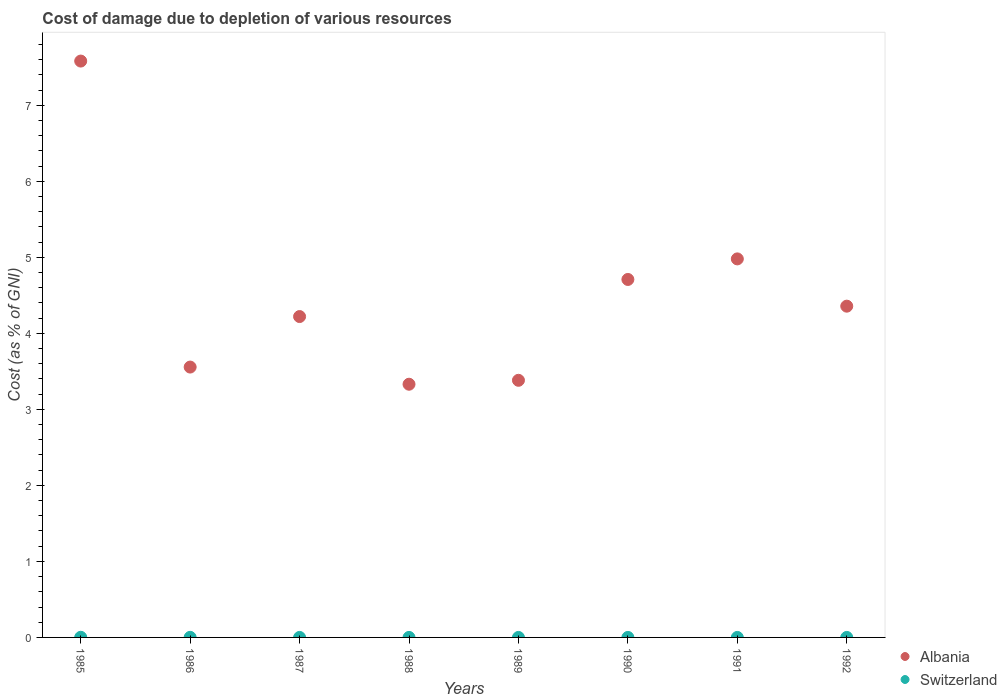What is the cost of damage caused due to the depletion of various resources in Albania in 1990?
Your response must be concise. 4.71. Across all years, what is the maximum cost of damage caused due to the depletion of various resources in Switzerland?
Your response must be concise. 0. Across all years, what is the minimum cost of damage caused due to the depletion of various resources in Albania?
Make the answer very short. 3.33. In which year was the cost of damage caused due to the depletion of various resources in Switzerland maximum?
Offer a very short reply. 1985. In which year was the cost of damage caused due to the depletion of various resources in Switzerland minimum?
Provide a succinct answer. 1992. What is the total cost of damage caused due to the depletion of various resources in Switzerland in the graph?
Give a very brief answer. 0. What is the difference between the cost of damage caused due to the depletion of various resources in Albania in 1987 and that in 1991?
Ensure brevity in your answer.  -0.76. What is the difference between the cost of damage caused due to the depletion of various resources in Switzerland in 1985 and the cost of damage caused due to the depletion of various resources in Albania in 1989?
Offer a very short reply. -3.38. What is the average cost of damage caused due to the depletion of various resources in Albania per year?
Offer a very short reply. 4.51. In the year 1992, what is the difference between the cost of damage caused due to the depletion of various resources in Switzerland and cost of damage caused due to the depletion of various resources in Albania?
Offer a terse response. -4.36. In how many years, is the cost of damage caused due to the depletion of various resources in Switzerland greater than 5.4 %?
Your response must be concise. 0. What is the ratio of the cost of damage caused due to the depletion of various resources in Albania in 1988 to that in 1989?
Your answer should be very brief. 0.98. What is the difference between the highest and the second highest cost of damage caused due to the depletion of various resources in Albania?
Provide a succinct answer. 2.6. What is the difference between the highest and the lowest cost of damage caused due to the depletion of various resources in Albania?
Provide a short and direct response. 4.25. In how many years, is the cost of damage caused due to the depletion of various resources in Switzerland greater than the average cost of damage caused due to the depletion of various resources in Switzerland taken over all years?
Give a very brief answer. 2. Is the sum of the cost of damage caused due to the depletion of various resources in Albania in 1990 and 1992 greater than the maximum cost of damage caused due to the depletion of various resources in Switzerland across all years?
Your answer should be very brief. Yes. Does the cost of damage caused due to the depletion of various resources in Albania monotonically increase over the years?
Provide a succinct answer. No. Is the cost of damage caused due to the depletion of various resources in Switzerland strictly greater than the cost of damage caused due to the depletion of various resources in Albania over the years?
Your response must be concise. No. Is the cost of damage caused due to the depletion of various resources in Albania strictly less than the cost of damage caused due to the depletion of various resources in Switzerland over the years?
Offer a very short reply. No. How many dotlines are there?
Offer a terse response. 2. What is the difference between two consecutive major ticks on the Y-axis?
Offer a very short reply. 1. Are the values on the major ticks of Y-axis written in scientific E-notation?
Your response must be concise. No. Does the graph contain grids?
Provide a short and direct response. No. How many legend labels are there?
Your response must be concise. 2. How are the legend labels stacked?
Provide a succinct answer. Vertical. What is the title of the graph?
Your answer should be very brief. Cost of damage due to depletion of various resources. What is the label or title of the X-axis?
Your answer should be very brief. Years. What is the label or title of the Y-axis?
Offer a very short reply. Cost (as % of GNI). What is the Cost (as % of GNI) in Albania in 1985?
Provide a short and direct response. 7.58. What is the Cost (as % of GNI) in Switzerland in 1985?
Keep it short and to the point. 0. What is the Cost (as % of GNI) in Albania in 1986?
Provide a succinct answer. 3.56. What is the Cost (as % of GNI) of Switzerland in 1986?
Make the answer very short. 0. What is the Cost (as % of GNI) of Albania in 1987?
Provide a short and direct response. 4.22. What is the Cost (as % of GNI) in Switzerland in 1987?
Make the answer very short. 0. What is the Cost (as % of GNI) in Albania in 1988?
Keep it short and to the point. 3.33. What is the Cost (as % of GNI) in Switzerland in 1988?
Ensure brevity in your answer.  9.86323820168902e-5. What is the Cost (as % of GNI) in Albania in 1989?
Your response must be concise. 3.38. What is the Cost (as % of GNI) of Switzerland in 1989?
Give a very brief answer. 5.30297084676029e-5. What is the Cost (as % of GNI) in Albania in 1990?
Provide a short and direct response. 4.71. What is the Cost (as % of GNI) of Switzerland in 1990?
Keep it short and to the point. 5.737427728367479e-5. What is the Cost (as % of GNI) of Albania in 1991?
Offer a very short reply. 4.98. What is the Cost (as % of GNI) of Switzerland in 1991?
Your answer should be compact. 4.359630859095721e-5. What is the Cost (as % of GNI) in Albania in 1992?
Your answer should be very brief. 4.36. What is the Cost (as % of GNI) of Switzerland in 1992?
Provide a short and direct response. 3.75649927603136e-5. Across all years, what is the maximum Cost (as % of GNI) of Albania?
Keep it short and to the point. 7.58. Across all years, what is the maximum Cost (as % of GNI) of Switzerland?
Make the answer very short. 0. Across all years, what is the minimum Cost (as % of GNI) of Albania?
Give a very brief answer. 3.33. Across all years, what is the minimum Cost (as % of GNI) in Switzerland?
Ensure brevity in your answer.  3.75649927603136e-5. What is the total Cost (as % of GNI) of Albania in the graph?
Your answer should be compact. 36.11. What is the total Cost (as % of GNI) of Switzerland in the graph?
Your answer should be very brief. 0. What is the difference between the Cost (as % of GNI) of Albania in 1985 and that in 1986?
Keep it short and to the point. 4.02. What is the difference between the Cost (as % of GNI) in Switzerland in 1985 and that in 1986?
Your answer should be very brief. 0. What is the difference between the Cost (as % of GNI) of Albania in 1985 and that in 1987?
Your response must be concise. 3.36. What is the difference between the Cost (as % of GNI) in Switzerland in 1985 and that in 1987?
Offer a terse response. 0. What is the difference between the Cost (as % of GNI) in Albania in 1985 and that in 1988?
Make the answer very short. 4.25. What is the difference between the Cost (as % of GNI) in Switzerland in 1985 and that in 1988?
Your answer should be compact. 0. What is the difference between the Cost (as % of GNI) in Albania in 1985 and that in 1989?
Make the answer very short. 4.2. What is the difference between the Cost (as % of GNI) in Switzerland in 1985 and that in 1989?
Your response must be concise. 0. What is the difference between the Cost (as % of GNI) in Albania in 1985 and that in 1990?
Your response must be concise. 2.87. What is the difference between the Cost (as % of GNI) of Switzerland in 1985 and that in 1990?
Ensure brevity in your answer.  0. What is the difference between the Cost (as % of GNI) in Albania in 1985 and that in 1991?
Offer a terse response. 2.6. What is the difference between the Cost (as % of GNI) of Switzerland in 1985 and that in 1991?
Offer a terse response. 0. What is the difference between the Cost (as % of GNI) in Albania in 1985 and that in 1992?
Your response must be concise. 3.22. What is the difference between the Cost (as % of GNI) in Switzerland in 1985 and that in 1992?
Offer a terse response. 0. What is the difference between the Cost (as % of GNI) of Albania in 1986 and that in 1987?
Keep it short and to the point. -0.66. What is the difference between the Cost (as % of GNI) of Switzerland in 1986 and that in 1987?
Make the answer very short. 0. What is the difference between the Cost (as % of GNI) in Albania in 1986 and that in 1988?
Offer a terse response. 0.23. What is the difference between the Cost (as % of GNI) of Switzerland in 1986 and that in 1988?
Your answer should be compact. 0. What is the difference between the Cost (as % of GNI) of Albania in 1986 and that in 1989?
Your answer should be very brief. 0.17. What is the difference between the Cost (as % of GNI) of Switzerland in 1986 and that in 1989?
Your answer should be very brief. 0. What is the difference between the Cost (as % of GNI) in Albania in 1986 and that in 1990?
Provide a succinct answer. -1.15. What is the difference between the Cost (as % of GNI) in Switzerland in 1986 and that in 1990?
Ensure brevity in your answer.  0. What is the difference between the Cost (as % of GNI) in Albania in 1986 and that in 1991?
Keep it short and to the point. -1.42. What is the difference between the Cost (as % of GNI) of Switzerland in 1986 and that in 1991?
Keep it short and to the point. 0. What is the difference between the Cost (as % of GNI) in Albania in 1986 and that in 1992?
Ensure brevity in your answer.  -0.8. What is the difference between the Cost (as % of GNI) of Switzerland in 1986 and that in 1992?
Keep it short and to the point. 0. What is the difference between the Cost (as % of GNI) of Albania in 1987 and that in 1988?
Ensure brevity in your answer.  0.89. What is the difference between the Cost (as % of GNI) in Switzerland in 1987 and that in 1988?
Ensure brevity in your answer.  0. What is the difference between the Cost (as % of GNI) in Albania in 1987 and that in 1989?
Offer a terse response. 0.84. What is the difference between the Cost (as % of GNI) in Albania in 1987 and that in 1990?
Ensure brevity in your answer.  -0.49. What is the difference between the Cost (as % of GNI) in Switzerland in 1987 and that in 1990?
Provide a short and direct response. 0. What is the difference between the Cost (as % of GNI) of Albania in 1987 and that in 1991?
Keep it short and to the point. -0.76. What is the difference between the Cost (as % of GNI) in Switzerland in 1987 and that in 1991?
Offer a very short reply. 0. What is the difference between the Cost (as % of GNI) in Albania in 1987 and that in 1992?
Make the answer very short. -0.14. What is the difference between the Cost (as % of GNI) in Switzerland in 1987 and that in 1992?
Provide a succinct answer. 0. What is the difference between the Cost (as % of GNI) of Albania in 1988 and that in 1989?
Give a very brief answer. -0.05. What is the difference between the Cost (as % of GNI) of Switzerland in 1988 and that in 1989?
Your answer should be compact. 0. What is the difference between the Cost (as % of GNI) in Albania in 1988 and that in 1990?
Give a very brief answer. -1.38. What is the difference between the Cost (as % of GNI) of Albania in 1988 and that in 1991?
Offer a very short reply. -1.65. What is the difference between the Cost (as % of GNI) in Albania in 1988 and that in 1992?
Give a very brief answer. -1.03. What is the difference between the Cost (as % of GNI) in Albania in 1989 and that in 1990?
Your answer should be very brief. -1.33. What is the difference between the Cost (as % of GNI) in Switzerland in 1989 and that in 1990?
Keep it short and to the point. -0. What is the difference between the Cost (as % of GNI) of Albania in 1989 and that in 1991?
Provide a succinct answer. -1.6. What is the difference between the Cost (as % of GNI) in Switzerland in 1989 and that in 1991?
Your answer should be compact. 0. What is the difference between the Cost (as % of GNI) of Albania in 1989 and that in 1992?
Offer a very short reply. -0.97. What is the difference between the Cost (as % of GNI) of Albania in 1990 and that in 1991?
Your answer should be compact. -0.27. What is the difference between the Cost (as % of GNI) of Albania in 1990 and that in 1992?
Your answer should be very brief. 0.35. What is the difference between the Cost (as % of GNI) in Albania in 1991 and that in 1992?
Your response must be concise. 0.62. What is the difference between the Cost (as % of GNI) in Switzerland in 1991 and that in 1992?
Keep it short and to the point. 0. What is the difference between the Cost (as % of GNI) in Albania in 1985 and the Cost (as % of GNI) in Switzerland in 1986?
Your answer should be compact. 7.58. What is the difference between the Cost (as % of GNI) in Albania in 1985 and the Cost (as % of GNI) in Switzerland in 1987?
Your response must be concise. 7.58. What is the difference between the Cost (as % of GNI) of Albania in 1985 and the Cost (as % of GNI) of Switzerland in 1988?
Your answer should be very brief. 7.58. What is the difference between the Cost (as % of GNI) of Albania in 1985 and the Cost (as % of GNI) of Switzerland in 1989?
Offer a terse response. 7.58. What is the difference between the Cost (as % of GNI) of Albania in 1985 and the Cost (as % of GNI) of Switzerland in 1990?
Your response must be concise. 7.58. What is the difference between the Cost (as % of GNI) of Albania in 1985 and the Cost (as % of GNI) of Switzerland in 1991?
Keep it short and to the point. 7.58. What is the difference between the Cost (as % of GNI) of Albania in 1985 and the Cost (as % of GNI) of Switzerland in 1992?
Offer a terse response. 7.58. What is the difference between the Cost (as % of GNI) in Albania in 1986 and the Cost (as % of GNI) in Switzerland in 1987?
Ensure brevity in your answer.  3.56. What is the difference between the Cost (as % of GNI) in Albania in 1986 and the Cost (as % of GNI) in Switzerland in 1988?
Provide a succinct answer. 3.56. What is the difference between the Cost (as % of GNI) in Albania in 1986 and the Cost (as % of GNI) in Switzerland in 1989?
Offer a very short reply. 3.56. What is the difference between the Cost (as % of GNI) in Albania in 1986 and the Cost (as % of GNI) in Switzerland in 1990?
Your response must be concise. 3.56. What is the difference between the Cost (as % of GNI) of Albania in 1986 and the Cost (as % of GNI) of Switzerland in 1991?
Keep it short and to the point. 3.56. What is the difference between the Cost (as % of GNI) of Albania in 1986 and the Cost (as % of GNI) of Switzerland in 1992?
Your answer should be compact. 3.56. What is the difference between the Cost (as % of GNI) of Albania in 1987 and the Cost (as % of GNI) of Switzerland in 1988?
Keep it short and to the point. 4.22. What is the difference between the Cost (as % of GNI) in Albania in 1987 and the Cost (as % of GNI) in Switzerland in 1989?
Make the answer very short. 4.22. What is the difference between the Cost (as % of GNI) in Albania in 1987 and the Cost (as % of GNI) in Switzerland in 1990?
Keep it short and to the point. 4.22. What is the difference between the Cost (as % of GNI) in Albania in 1987 and the Cost (as % of GNI) in Switzerland in 1991?
Give a very brief answer. 4.22. What is the difference between the Cost (as % of GNI) in Albania in 1987 and the Cost (as % of GNI) in Switzerland in 1992?
Your answer should be compact. 4.22. What is the difference between the Cost (as % of GNI) in Albania in 1988 and the Cost (as % of GNI) in Switzerland in 1989?
Your answer should be very brief. 3.33. What is the difference between the Cost (as % of GNI) of Albania in 1988 and the Cost (as % of GNI) of Switzerland in 1990?
Your answer should be compact. 3.33. What is the difference between the Cost (as % of GNI) in Albania in 1988 and the Cost (as % of GNI) in Switzerland in 1991?
Give a very brief answer. 3.33. What is the difference between the Cost (as % of GNI) of Albania in 1988 and the Cost (as % of GNI) of Switzerland in 1992?
Keep it short and to the point. 3.33. What is the difference between the Cost (as % of GNI) in Albania in 1989 and the Cost (as % of GNI) in Switzerland in 1990?
Your answer should be compact. 3.38. What is the difference between the Cost (as % of GNI) in Albania in 1989 and the Cost (as % of GNI) in Switzerland in 1991?
Your answer should be very brief. 3.38. What is the difference between the Cost (as % of GNI) of Albania in 1989 and the Cost (as % of GNI) of Switzerland in 1992?
Your answer should be compact. 3.38. What is the difference between the Cost (as % of GNI) of Albania in 1990 and the Cost (as % of GNI) of Switzerland in 1991?
Ensure brevity in your answer.  4.71. What is the difference between the Cost (as % of GNI) in Albania in 1990 and the Cost (as % of GNI) in Switzerland in 1992?
Your answer should be compact. 4.71. What is the difference between the Cost (as % of GNI) of Albania in 1991 and the Cost (as % of GNI) of Switzerland in 1992?
Offer a very short reply. 4.98. What is the average Cost (as % of GNI) of Albania per year?
Provide a short and direct response. 4.51. What is the average Cost (as % of GNI) in Switzerland per year?
Make the answer very short. 0. In the year 1985, what is the difference between the Cost (as % of GNI) in Albania and Cost (as % of GNI) in Switzerland?
Offer a very short reply. 7.58. In the year 1986, what is the difference between the Cost (as % of GNI) of Albania and Cost (as % of GNI) of Switzerland?
Provide a succinct answer. 3.55. In the year 1987, what is the difference between the Cost (as % of GNI) of Albania and Cost (as % of GNI) of Switzerland?
Keep it short and to the point. 4.22. In the year 1988, what is the difference between the Cost (as % of GNI) of Albania and Cost (as % of GNI) of Switzerland?
Provide a short and direct response. 3.33. In the year 1989, what is the difference between the Cost (as % of GNI) in Albania and Cost (as % of GNI) in Switzerland?
Offer a very short reply. 3.38. In the year 1990, what is the difference between the Cost (as % of GNI) in Albania and Cost (as % of GNI) in Switzerland?
Offer a very short reply. 4.71. In the year 1991, what is the difference between the Cost (as % of GNI) of Albania and Cost (as % of GNI) of Switzerland?
Offer a very short reply. 4.98. In the year 1992, what is the difference between the Cost (as % of GNI) in Albania and Cost (as % of GNI) in Switzerland?
Keep it short and to the point. 4.36. What is the ratio of the Cost (as % of GNI) of Albania in 1985 to that in 1986?
Your response must be concise. 2.13. What is the ratio of the Cost (as % of GNI) of Switzerland in 1985 to that in 1986?
Your answer should be very brief. 1.59. What is the ratio of the Cost (as % of GNI) in Albania in 1985 to that in 1987?
Your answer should be very brief. 1.8. What is the ratio of the Cost (as % of GNI) of Switzerland in 1985 to that in 1987?
Offer a terse response. 12. What is the ratio of the Cost (as % of GNI) in Albania in 1985 to that in 1988?
Offer a terse response. 2.28. What is the ratio of the Cost (as % of GNI) of Switzerland in 1985 to that in 1988?
Give a very brief answer. 18.59. What is the ratio of the Cost (as % of GNI) of Albania in 1985 to that in 1989?
Your response must be concise. 2.24. What is the ratio of the Cost (as % of GNI) in Switzerland in 1985 to that in 1989?
Your response must be concise. 34.57. What is the ratio of the Cost (as % of GNI) in Albania in 1985 to that in 1990?
Give a very brief answer. 1.61. What is the ratio of the Cost (as % of GNI) of Switzerland in 1985 to that in 1990?
Your answer should be very brief. 31.95. What is the ratio of the Cost (as % of GNI) in Albania in 1985 to that in 1991?
Your response must be concise. 1.52. What is the ratio of the Cost (as % of GNI) of Switzerland in 1985 to that in 1991?
Give a very brief answer. 42.05. What is the ratio of the Cost (as % of GNI) in Albania in 1985 to that in 1992?
Your response must be concise. 1.74. What is the ratio of the Cost (as % of GNI) of Switzerland in 1985 to that in 1992?
Offer a terse response. 48.8. What is the ratio of the Cost (as % of GNI) of Albania in 1986 to that in 1987?
Offer a very short reply. 0.84. What is the ratio of the Cost (as % of GNI) in Switzerland in 1986 to that in 1987?
Ensure brevity in your answer.  7.56. What is the ratio of the Cost (as % of GNI) in Albania in 1986 to that in 1988?
Your answer should be compact. 1.07. What is the ratio of the Cost (as % of GNI) of Switzerland in 1986 to that in 1988?
Provide a short and direct response. 11.71. What is the ratio of the Cost (as % of GNI) of Albania in 1986 to that in 1989?
Provide a short and direct response. 1.05. What is the ratio of the Cost (as % of GNI) of Switzerland in 1986 to that in 1989?
Your response must be concise. 21.78. What is the ratio of the Cost (as % of GNI) in Albania in 1986 to that in 1990?
Ensure brevity in your answer.  0.76. What is the ratio of the Cost (as % of GNI) in Switzerland in 1986 to that in 1990?
Keep it short and to the point. 20.13. What is the ratio of the Cost (as % of GNI) of Albania in 1986 to that in 1991?
Ensure brevity in your answer.  0.71. What is the ratio of the Cost (as % of GNI) of Switzerland in 1986 to that in 1991?
Give a very brief answer. 26.49. What is the ratio of the Cost (as % of GNI) of Albania in 1986 to that in 1992?
Make the answer very short. 0.82. What is the ratio of the Cost (as % of GNI) in Switzerland in 1986 to that in 1992?
Offer a terse response. 30.75. What is the ratio of the Cost (as % of GNI) of Albania in 1987 to that in 1988?
Ensure brevity in your answer.  1.27. What is the ratio of the Cost (as % of GNI) in Switzerland in 1987 to that in 1988?
Provide a short and direct response. 1.55. What is the ratio of the Cost (as % of GNI) of Albania in 1987 to that in 1989?
Offer a very short reply. 1.25. What is the ratio of the Cost (as % of GNI) in Switzerland in 1987 to that in 1989?
Provide a succinct answer. 2.88. What is the ratio of the Cost (as % of GNI) in Albania in 1987 to that in 1990?
Your response must be concise. 0.9. What is the ratio of the Cost (as % of GNI) of Switzerland in 1987 to that in 1990?
Ensure brevity in your answer.  2.66. What is the ratio of the Cost (as % of GNI) of Albania in 1987 to that in 1991?
Provide a short and direct response. 0.85. What is the ratio of the Cost (as % of GNI) of Switzerland in 1987 to that in 1991?
Your answer should be very brief. 3.51. What is the ratio of the Cost (as % of GNI) in Albania in 1987 to that in 1992?
Make the answer very short. 0.97. What is the ratio of the Cost (as % of GNI) of Switzerland in 1987 to that in 1992?
Offer a terse response. 4.07. What is the ratio of the Cost (as % of GNI) of Albania in 1988 to that in 1989?
Your response must be concise. 0.98. What is the ratio of the Cost (as % of GNI) in Switzerland in 1988 to that in 1989?
Provide a short and direct response. 1.86. What is the ratio of the Cost (as % of GNI) in Albania in 1988 to that in 1990?
Give a very brief answer. 0.71. What is the ratio of the Cost (as % of GNI) in Switzerland in 1988 to that in 1990?
Offer a very short reply. 1.72. What is the ratio of the Cost (as % of GNI) of Albania in 1988 to that in 1991?
Your answer should be compact. 0.67. What is the ratio of the Cost (as % of GNI) in Switzerland in 1988 to that in 1991?
Your response must be concise. 2.26. What is the ratio of the Cost (as % of GNI) of Albania in 1988 to that in 1992?
Provide a succinct answer. 0.76. What is the ratio of the Cost (as % of GNI) in Switzerland in 1988 to that in 1992?
Your response must be concise. 2.63. What is the ratio of the Cost (as % of GNI) of Albania in 1989 to that in 1990?
Your answer should be compact. 0.72. What is the ratio of the Cost (as % of GNI) of Switzerland in 1989 to that in 1990?
Ensure brevity in your answer.  0.92. What is the ratio of the Cost (as % of GNI) of Albania in 1989 to that in 1991?
Provide a short and direct response. 0.68. What is the ratio of the Cost (as % of GNI) in Switzerland in 1989 to that in 1991?
Offer a terse response. 1.22. What is the ratio of the Cost (as % of GNI) in Albania in 1989 to that in 1992?
Ensure brevity in your answer.  0.78. What is the ratio of the Cost (as % of GNI) of Switzerland in 1989 to that in 1992?
Provide a short and direct response. 1.41. What is the ratio of the Cost (as % of GNI) of Albania in 1990 to that in 1991?
Offer a very short reply. 0.95. What is the ratio of the Cost (as % of GNI) of Switzerland in 1990 to that in 1991?
Provide a short and direct response. 1.32. What is the ratio of the Cost (as % of GNI) in Albania in 1990 to that in 1992?
Make the answer very short. 1.08. What is the ratio of the Cost (as % of GNI) in Switzerland in 1990 to that in 1992?
Provide a succinct answer. 1.53. What is the ratio of the Cost (as % of GNI) of Albania in 1991 to that in 1992?
Your answer should be compact. 1.14. What is the ratio of the Cost (as % of GNI) in Switzerland in 1991 to that in 1992?
Offer a terse response. 1.16. What is the difference between the highest and the second highest Cost (as % of GNI) in Albania?
Provide a short and direct response. 2.6. What is the difference between the highest and the second highest Cost (as % of GNI) in Switzerland?
Your response must be concise. 0. What is the difference between the highest and the lowest Cost (as % of GNI) of Albania?
Your answer should be very brief. 4.25. What is the difference between the highest and the lowest Cost (as % of GNI) in Switzerland?
Your answer should be compact. 0. 